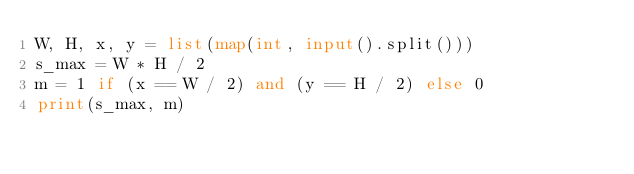<code> <loc_0><loc_0><loc_500><loc_500><_Python_>W, H, x, y = list(map(int, input().split()))
s_max = W * H / 2
m = 1 if (x == W / 2) and (y == H / 2) else 0
print(s_max, m)
</code> 